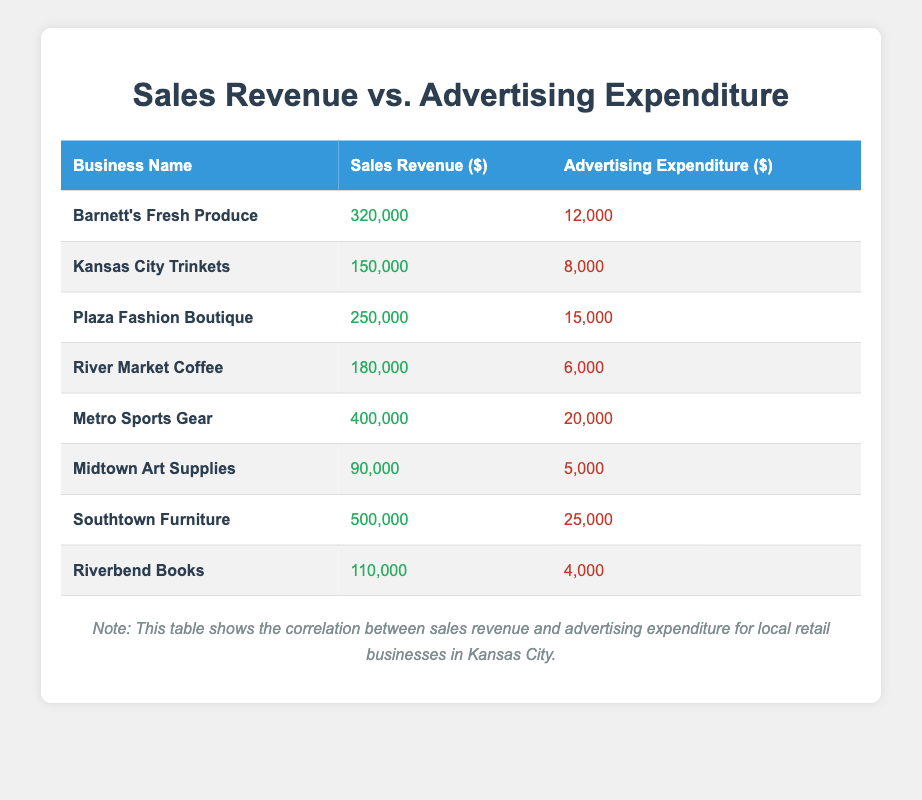What is the sales revenue for Southtown Furniture? The table shows that Southtown Furniture has a sales revenue listed under the "Sales Revenue ($)" column, which is 500,000.
Answer: 500000 Which business has the highest advertising expenditure? By inspecting the "Advertising Expenditure ($)" column, the maximum expenditure value is 25,000, which corresponds to Southtown Furniture.
Answer: Southtown Furniture What is the total sales revenue of all businesses listed in the table? To find the total sales revenue, I will sum the sales revenues: 320000 + 150000 + 250000 + 180000 + 400000 + 90000 + 500000 + 110000 = 1880000.
Answer: 1880000 Is the advertising expenditure for Plaza Fashion Boutique greater than 10,000? Looking at the table, Plaza Fashion Boutique's advertising expenditure is 15,000, which is greater than 10,000.
Answer: Yes What is the average advertising expenditure for the listed businesses? To find the average, I need to sum all advertising expenditures (12000 + 8000 + 15000 + 6000 + 20000 + 5000 + 25000 + 4000 = 100000) and divide by the number of businesses (8). The average is 100000 / 8 = 12500.
Answer: 12500 Which business has a sales revenue less than 150,000? Looking at the "Sales Revenue ($)" column, Midtown Art Supplies has a sales revenue of 90,000, which is less than 150,000.
Answer: Midtown Art Supplies What is the difference between the highest and lowest sales revenue in this table? The highest sales revenue is from Southtown Furniture at 500,000 and the lowest is Midtown Art Supplies at 90,000. The difference is 500000 - 90000 = 410000.
Answer: 410000 Does any business have sales revenue equal to its advertising expenditure? Upon reviewing the table, no business shows that their sales revenue is equal to their advertising expenditure.
Answer: No 